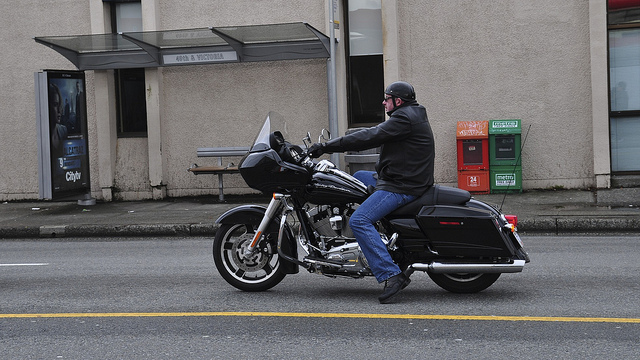<image>How old is the man? I don't know how old the man is. The age could be in the range of 35 to 52. How old is the man? It is unanswerable how old is the man. There are multiple different answers provided. 